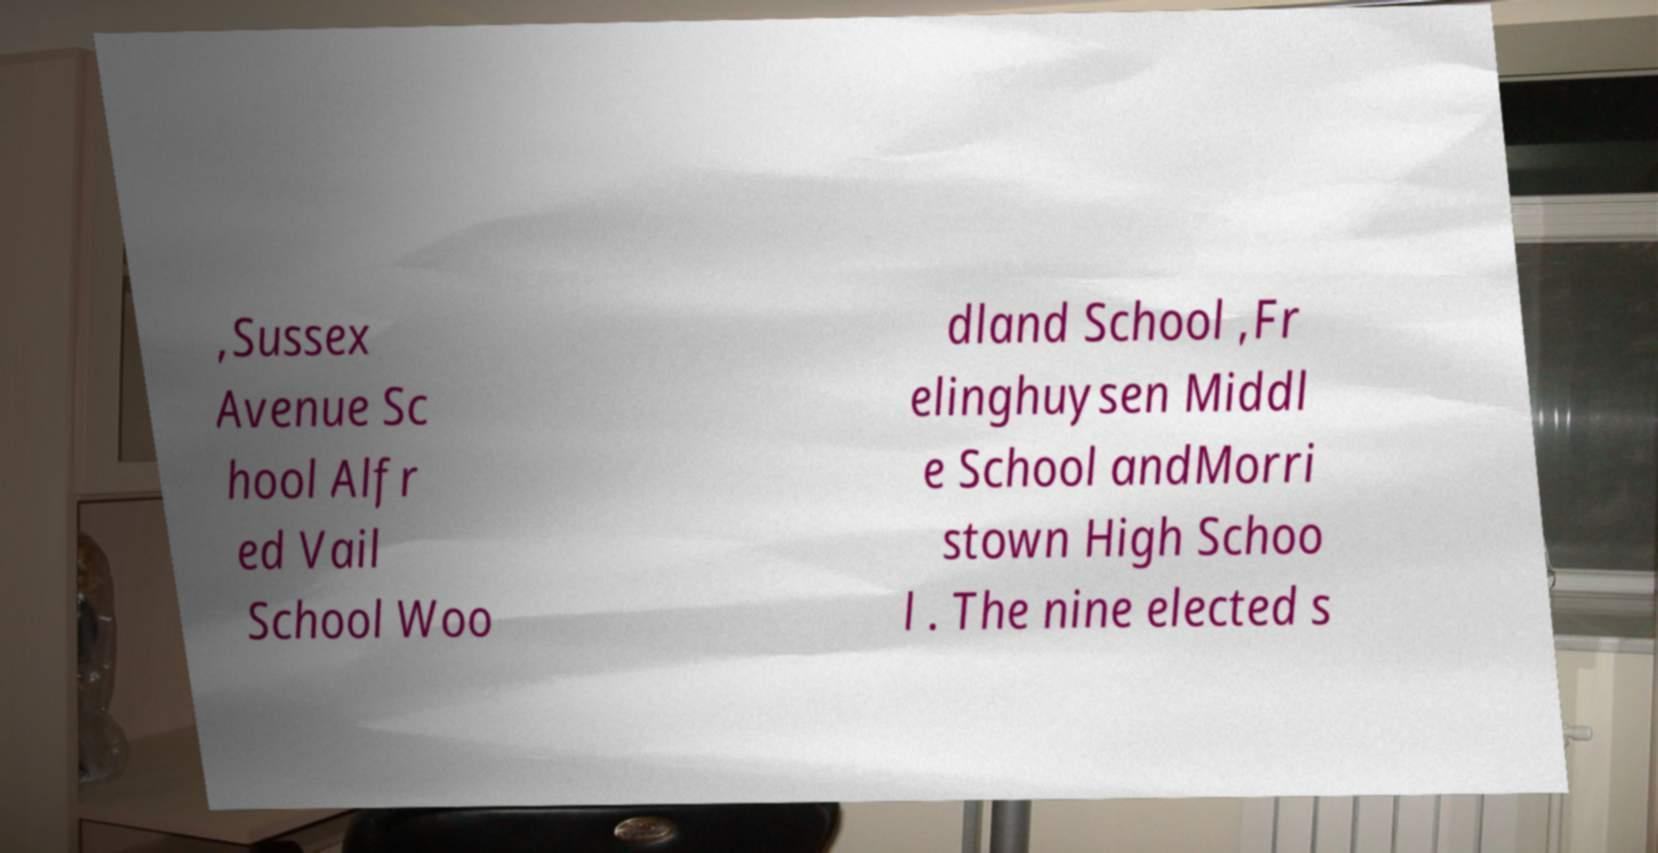What messages or text are displayed in this image? I need them in a readable, typed format. ,Sussex Avenue Sc hool Alfr ed Vail School Woo dland School ,Fr elinghuysen Middl e School andMorri stown High Schoo l . The nine elected s 